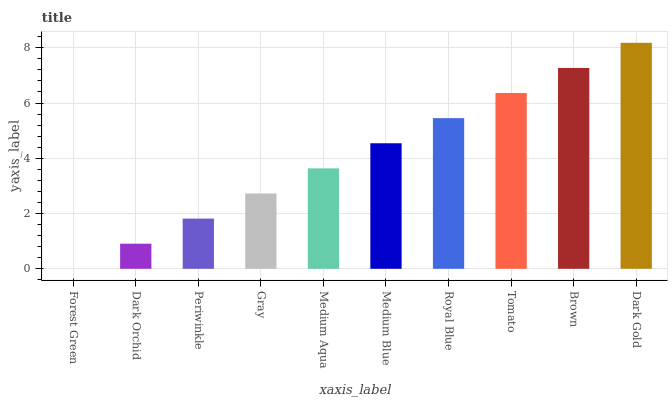Is Forest Green the minimum?
Answer yes or no. Yes. Is Dark Gold the maximum?
Answer yes or no. Yes. Is Dark Orchid the minimum?
Answer yes or no. No. Is Dark Orchid the maximum?
Answer yes or no. No. Is Dark Orchid greater than Forest Green?
Answer yes or no. Yes. Is Forest Green less than Dark Orchid?
Answer yes or no. Yes. Is Forest Green greater than Dark Orchid?
Answer yes or no. No. Is Dark Orchid less than Forest Green?
Answer yes or no. No. Is Medium Blue the high median?
Answer yes or no. Yes. Is Medium Aqua the low median?
Answer yes or no. Yes. Is Periwinkle the high median?
Answer yes or no. No. Is Royal Blue the low median?
Answer yes or no. No. 